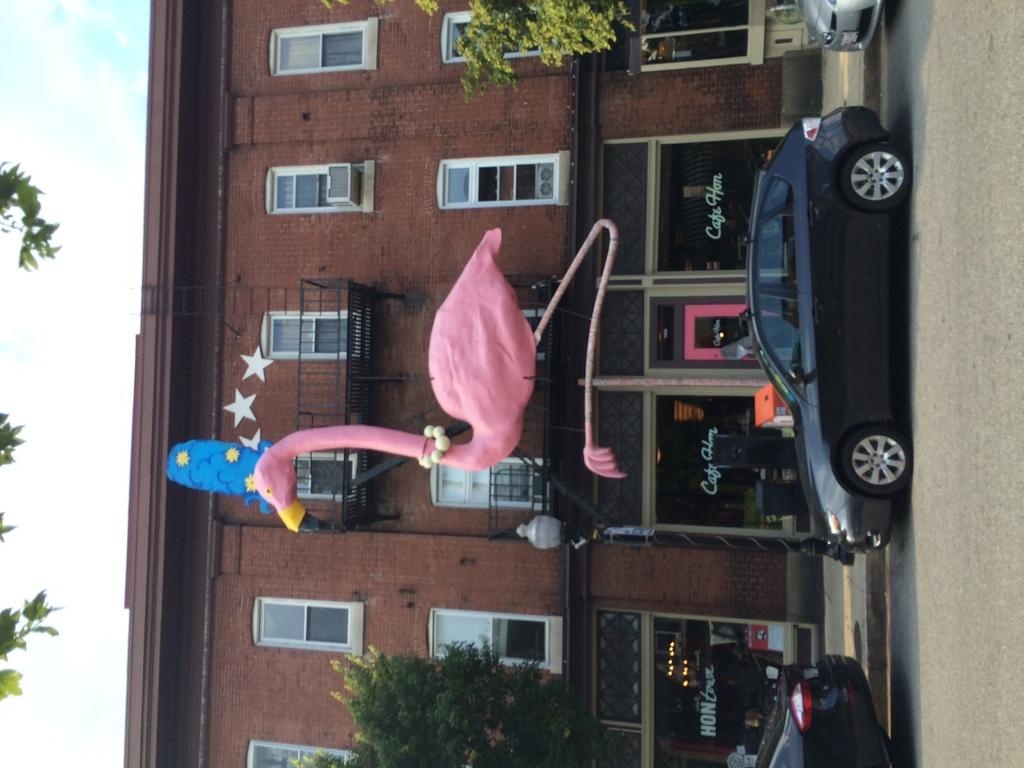What type of structure is present in the image? There is a building in the image. What can be found inside the building? There are stores in the image. What natural elements are visible in the image? There are trees in the image. What artificial elements are visible in the image? There are lights, vehicles, a board, poles, and objects in the image. What is the statue in the image depicting? The specific subject of the statue is not mentioned in the facts, so we cannot determine what it is depicting. What type of error can be seen in the image? There is no mention of an error in the image, so we cannot determine if there is any error present. What type of loaf is being sold in the stores in the image? There is no information about specific items being sold in the stores, so we cannot determine if any loaves are being sold. 